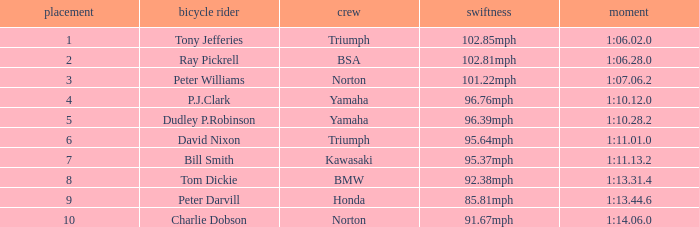Which Rider has a 1:06.02.0 Time? Tony Jefferies. 